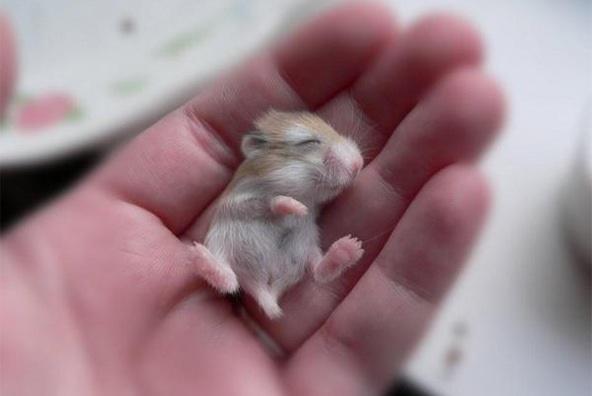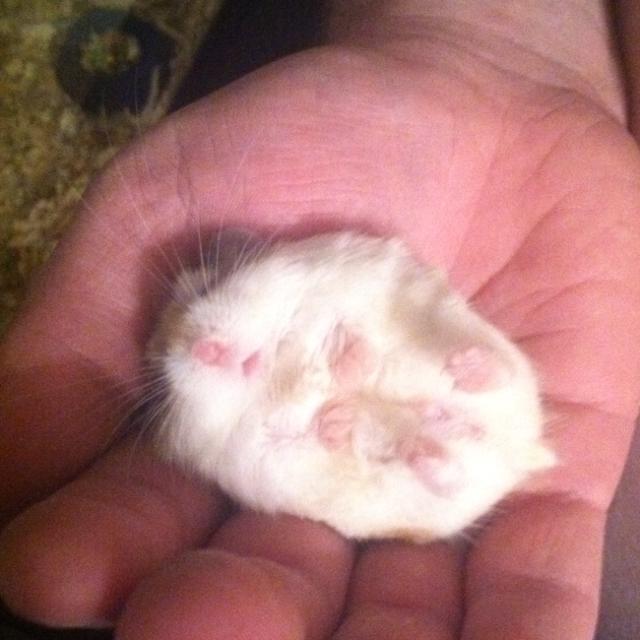The first image is the image on the left, the second image is the image on the right. For the images shown, is this caption "A mouse is asleep in at least one of the images." true? Answer yes or no. Yes. The first image is the image on the left, the second image is the image on the right. For the images shown, is this caption "In each image, one hand is palm up holding one pet rodent." true? Answer yes or no. Yes. 